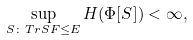<formula> <loc_0><loc_0><loc_500><loc_500>\sup _ { S \colon T r S F \leq E } H ( \Phi [ S ] ) < \infty ,</formula> 